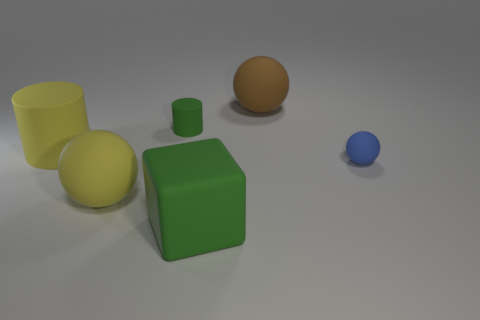Subtract all cylinders. How many objects are left? 4 Add 2 brown blocks. How many objects exist? 8 Subtract all blue spheres. How many spheres are left? 2 Subtract all green cylinders. How many cylinders are left? 1 Subtract 2 balls. How many balls are left? 1 Subtract all purple balls. How many purple cylinders are left? 0 Subtract all yellow things. Subtract all green objects. How many objects are left? 2 Add 2 tiny cylinders. How many tiny cylinders are left? 3 Add 4 yellow things. How many yellow things exist? 6 Subtract 1 yellow balls. How many objects are left? 5 